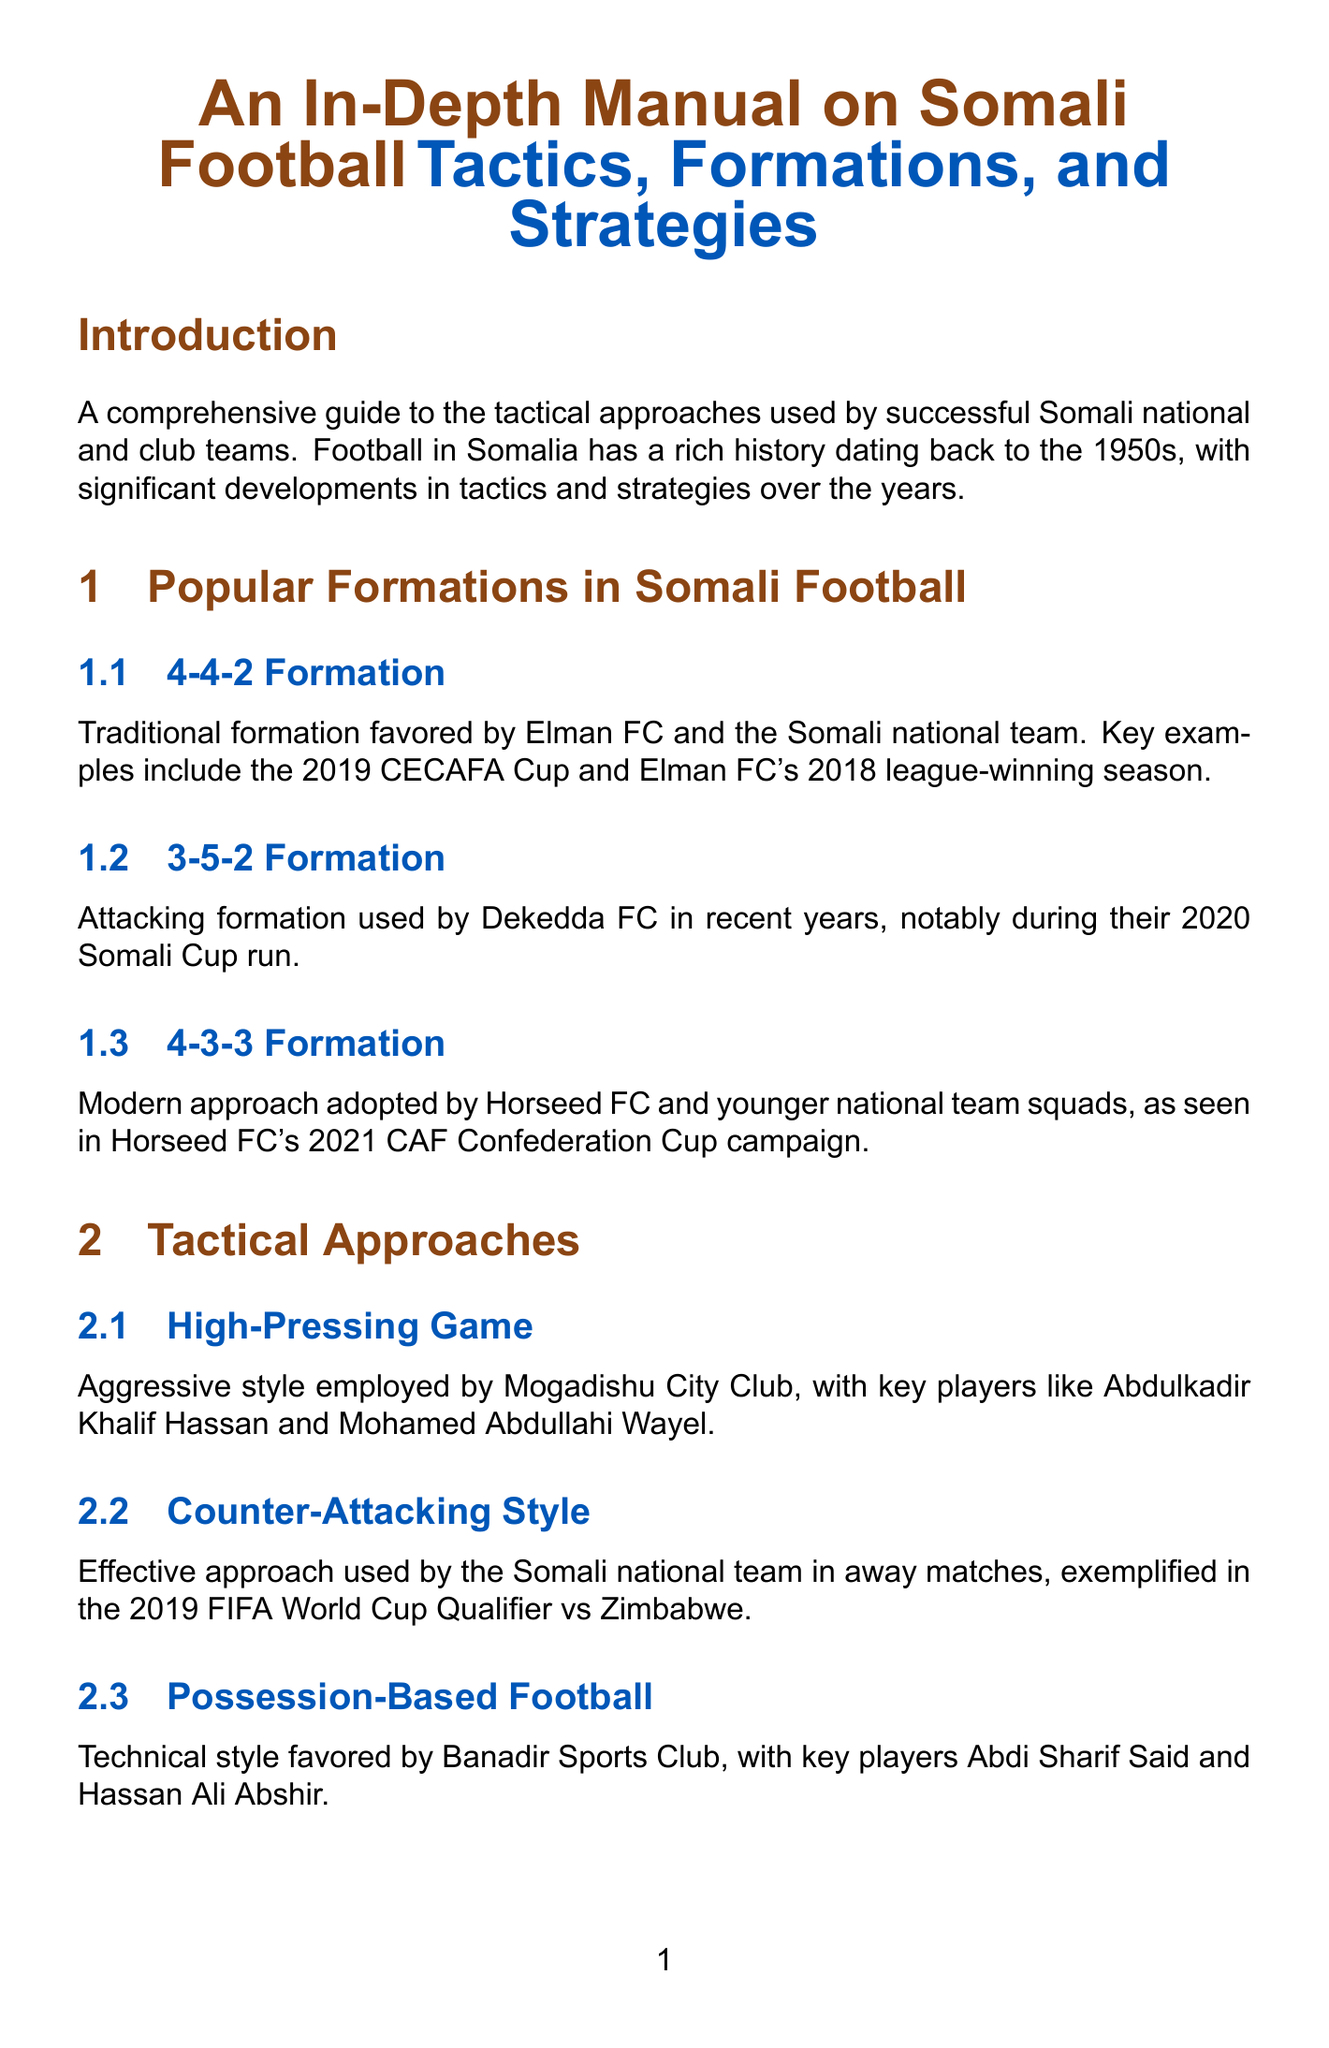what is the traditional formation favored by Elman FC? The 4-4-2 Formation is the traditional formation favored by Elman FC.
Answer: 4-4-2 Formation which club uses the 3-5-2 formation? Dekedda FC is known for using the 3-5-2 Formation in recent years.
Answer: Dekedda FC what style is favored by Banadir Sports Club? Banadir Sports Club favors Possession-Based Football.
Answer: Possession-Based Football who are the key players in the high-pressing game? Abdulkadir Khalif Hassan and Mohamed Abdullahi Wayel are the key players in the high-pressing game.
Answer: Abdulkadir Khalif Hassan, Mohamed Abdullahi Wayel what match exemplifies the counter-attacking style? The 2019 FIFA World Cup Qualifier vs Zimbabwe exemplifies the counter-attacking style used by the Somali national team.
Answer: 2019 FIFA World Cup Qualifier vs Zimbabwe what is one innovative corner kick routine used by Somali teams? One innovative corner kick routine is Mogadishu City Club's near-post flick-on.
Answer: Mogadishu City Club's near-post flick-on who is a key player for free-kick techniques? Liban Abdi is a key player for free-kick techniques.
Answer: Liban Abdi what does the Somali Football Federation promote for youth? The Somali Football Federation promotes tactical awareness through SFF Coaching Courses.
Answer: SFF Coaching Courses which formation is adopted by Horseed FC? Horseed FC adopts the 4-3-3 Formation.
Answer: 4-3-3 Formation 